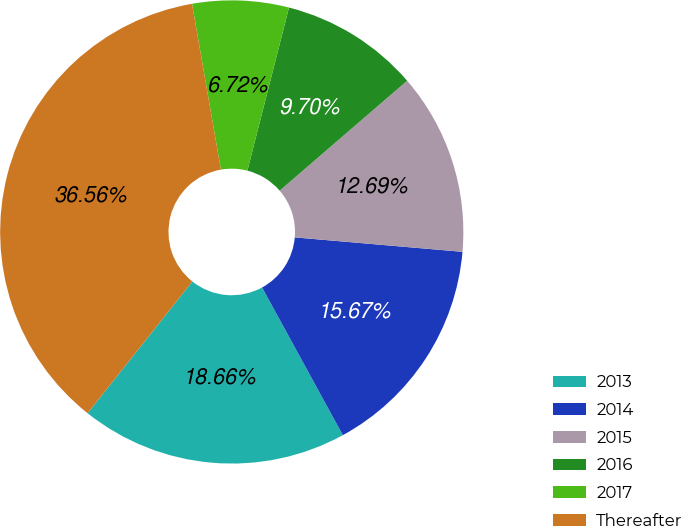Convert chart. <chart><loc_0><loc_0><loc_500><loc_500><pie_chart><fcel>2013<fcel>2014<fcel>2015<fcel>2016<fcel>2017<fcel>Thereafter<nl><fcel>18.66%<fcel>15.67%<fcel>12.69%<fcel>9.7%<fcel>6.72%<fcel>36.56%<nl></chart> 